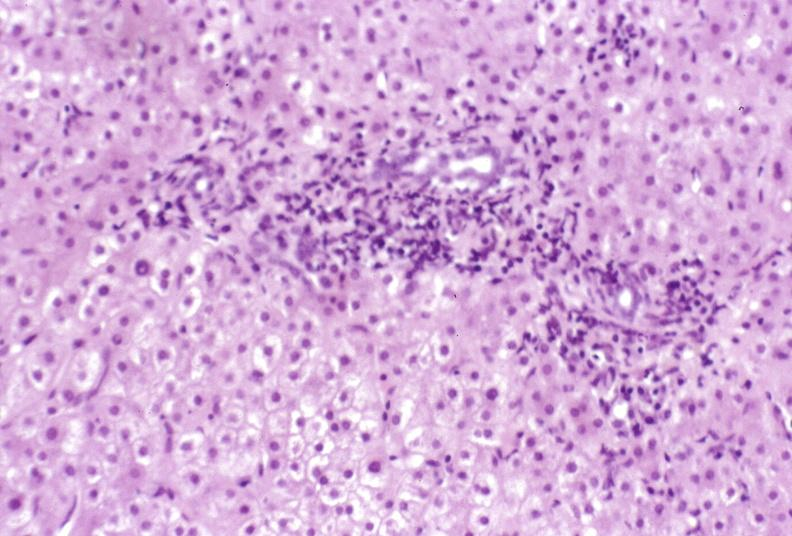s hepatobiliary present?
Answer the question using a single word or phrase. Yes 